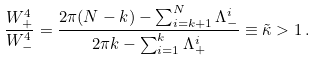Convert formula to latex. <formula><loc_0><loc_0><loc_500><loc_500>\frac { W ^ { 4 } _ { + } } { W ^ { 4 } _ { - } } & = \frac { 2 \pi ( N - k ) - \sum _ { i = k + 1 } ^ { N } \Lambda ^ { i } _ { - } } { 2 \pi k - \sum _ { i = 1 } ^ { k } \Lambda ^ { i } _ { + } } \equiv \tilde { \kappa } > 1 \, .</formula> 